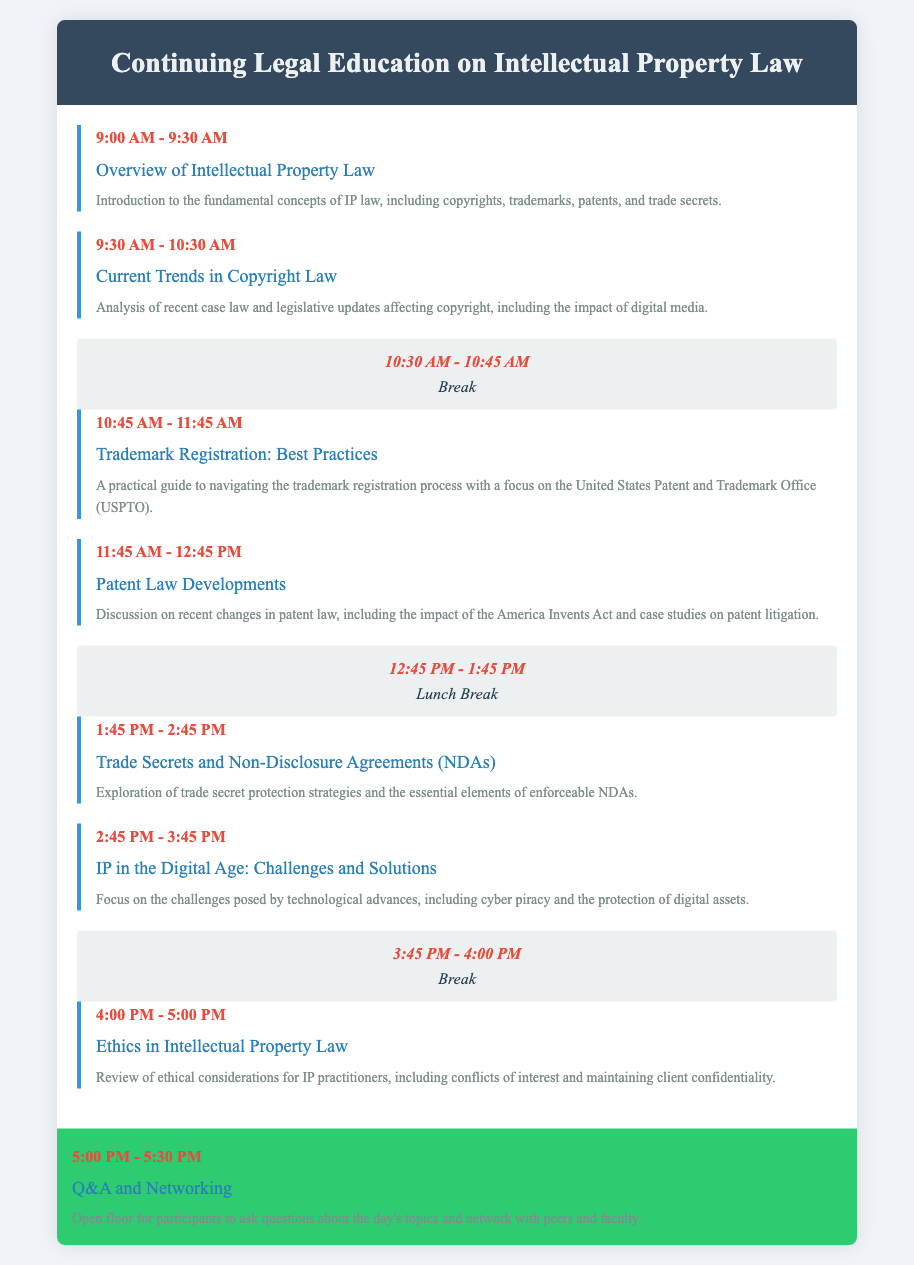What time does the CLE program start? The starting time is clearly indicated in the agenda and is listed as 9:00 AM.
Answer: 9:00 AM What is the title of the session at 10:45 AM? The agenda lists the title of the session at 10:45 AM as "Trademark Registration: Best Practices".
Answer: Trademark Registration: Best Practices How long is the lunch break? The agenda specifies the lunch break duration, which is 1 hour, from 12:45 PM to 1:45 PM.
Answer: 1 hour What is the focus of the session on "IP in the Digital Age"? The details of this session explain that it addresses challenges posed by technological advances.
Answer: Challenges posed by technological advances Which session covers ethics in Intellectual Property law? The title of the session addressing ethics is "Ethics in Intellectual Property Law" listed at 4:00 PM.
Answer: Ethics in Intellectual Property Law What is included in the conclusion of the agenda? The conclusion section encompasses a Q&A and networking opportunity for participants.
Answer: Q&A and Networking How many sessions are scheduled before the lunch break? By counting the sessions listed before 12:45 PM, there are four sessions before the lunch break.
Answer: Four sessions What type of law is the CLE program focused on? The title and content of the program indicate that it is focused on Intellectual Property Law.
Answer: Intellectual Property Law 